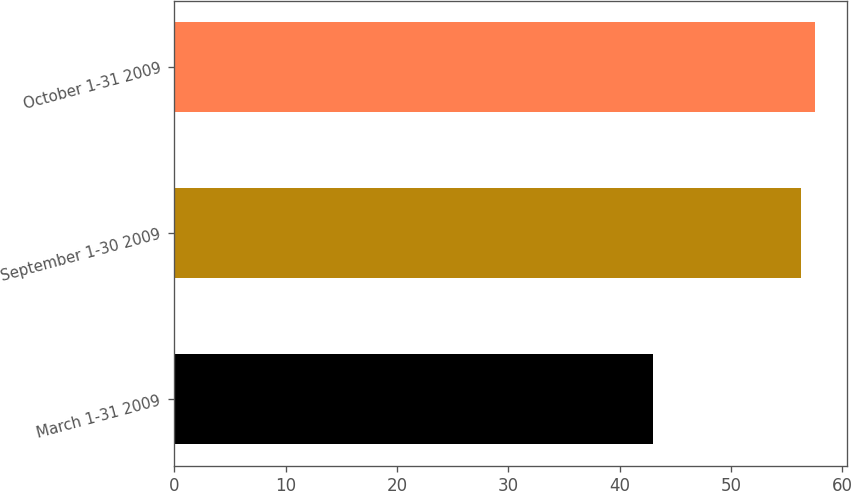<chart> <loc_0><loc_0><loc_500><loc_500><bar_chart><fcel>March 1-31 2009<fcel>September 1-30 2009<fcel>October 1-31 2009<nl><fcel>43.01<fcel>56.25<fcel>57.58<nl></chart> 